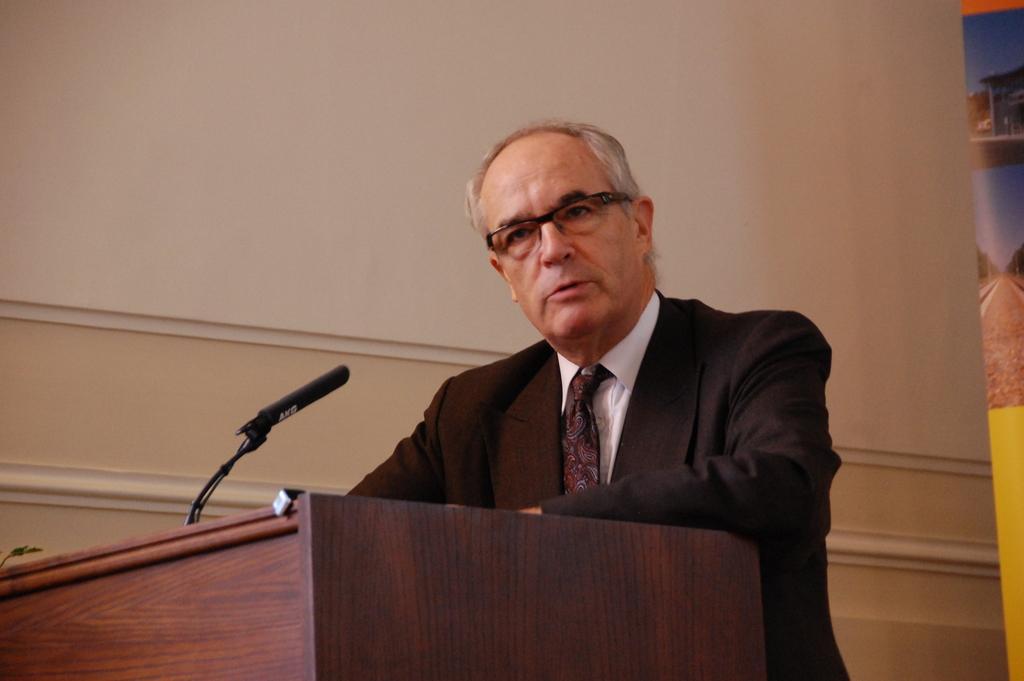In one or two sentences, can you explain what this image depicts? In the picture we can see a person wearing suit, also spectacles standing behind wooden podium on which there is microphone and in the background there is a wall. 